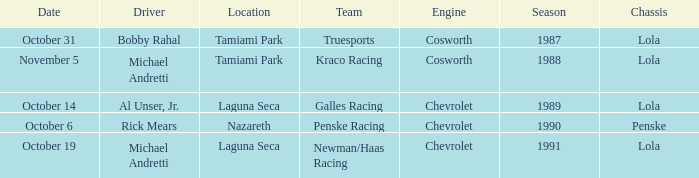What engine does Galles Racing use? Chevrolet. 